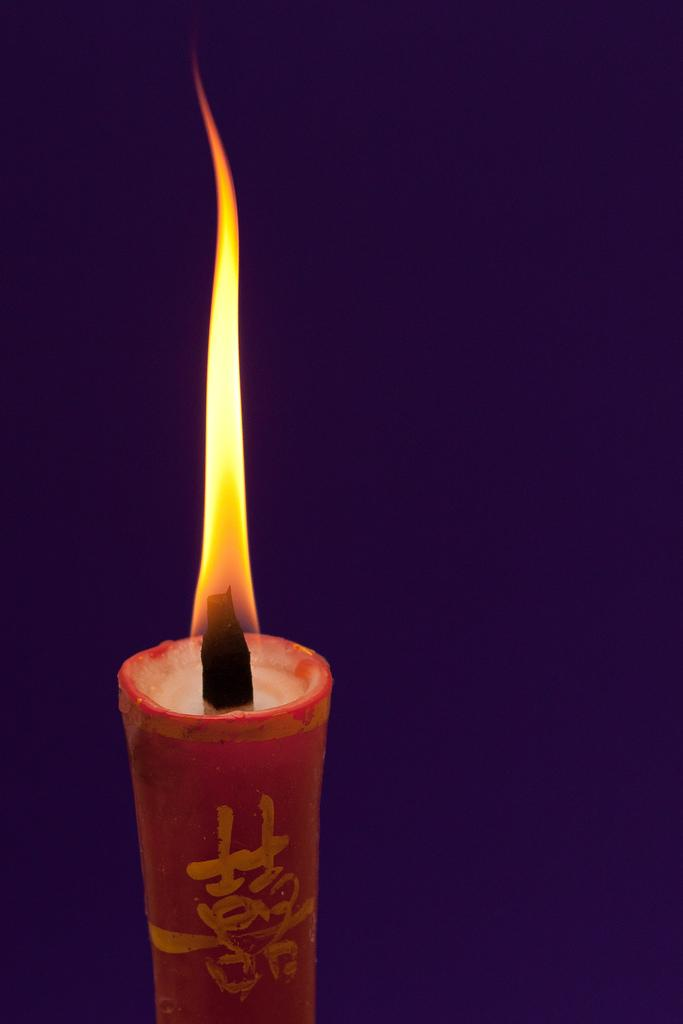What object is present in the image that produces light? There is a candle in the image that produces light. What color is the candle in the image? The candle is red in color. What is the state of the candle in the image? The candle has a flame on it. What colors can be seen in the flame of the candle? The flame has orange and yellow colors. What color is the background of the image? The background of the image is purple. What type of sister is shown helping with the selection of ingredients in the image? There is no sister or selection of ingredients present in the image; it only features a red candle with a flame and a purple background. 